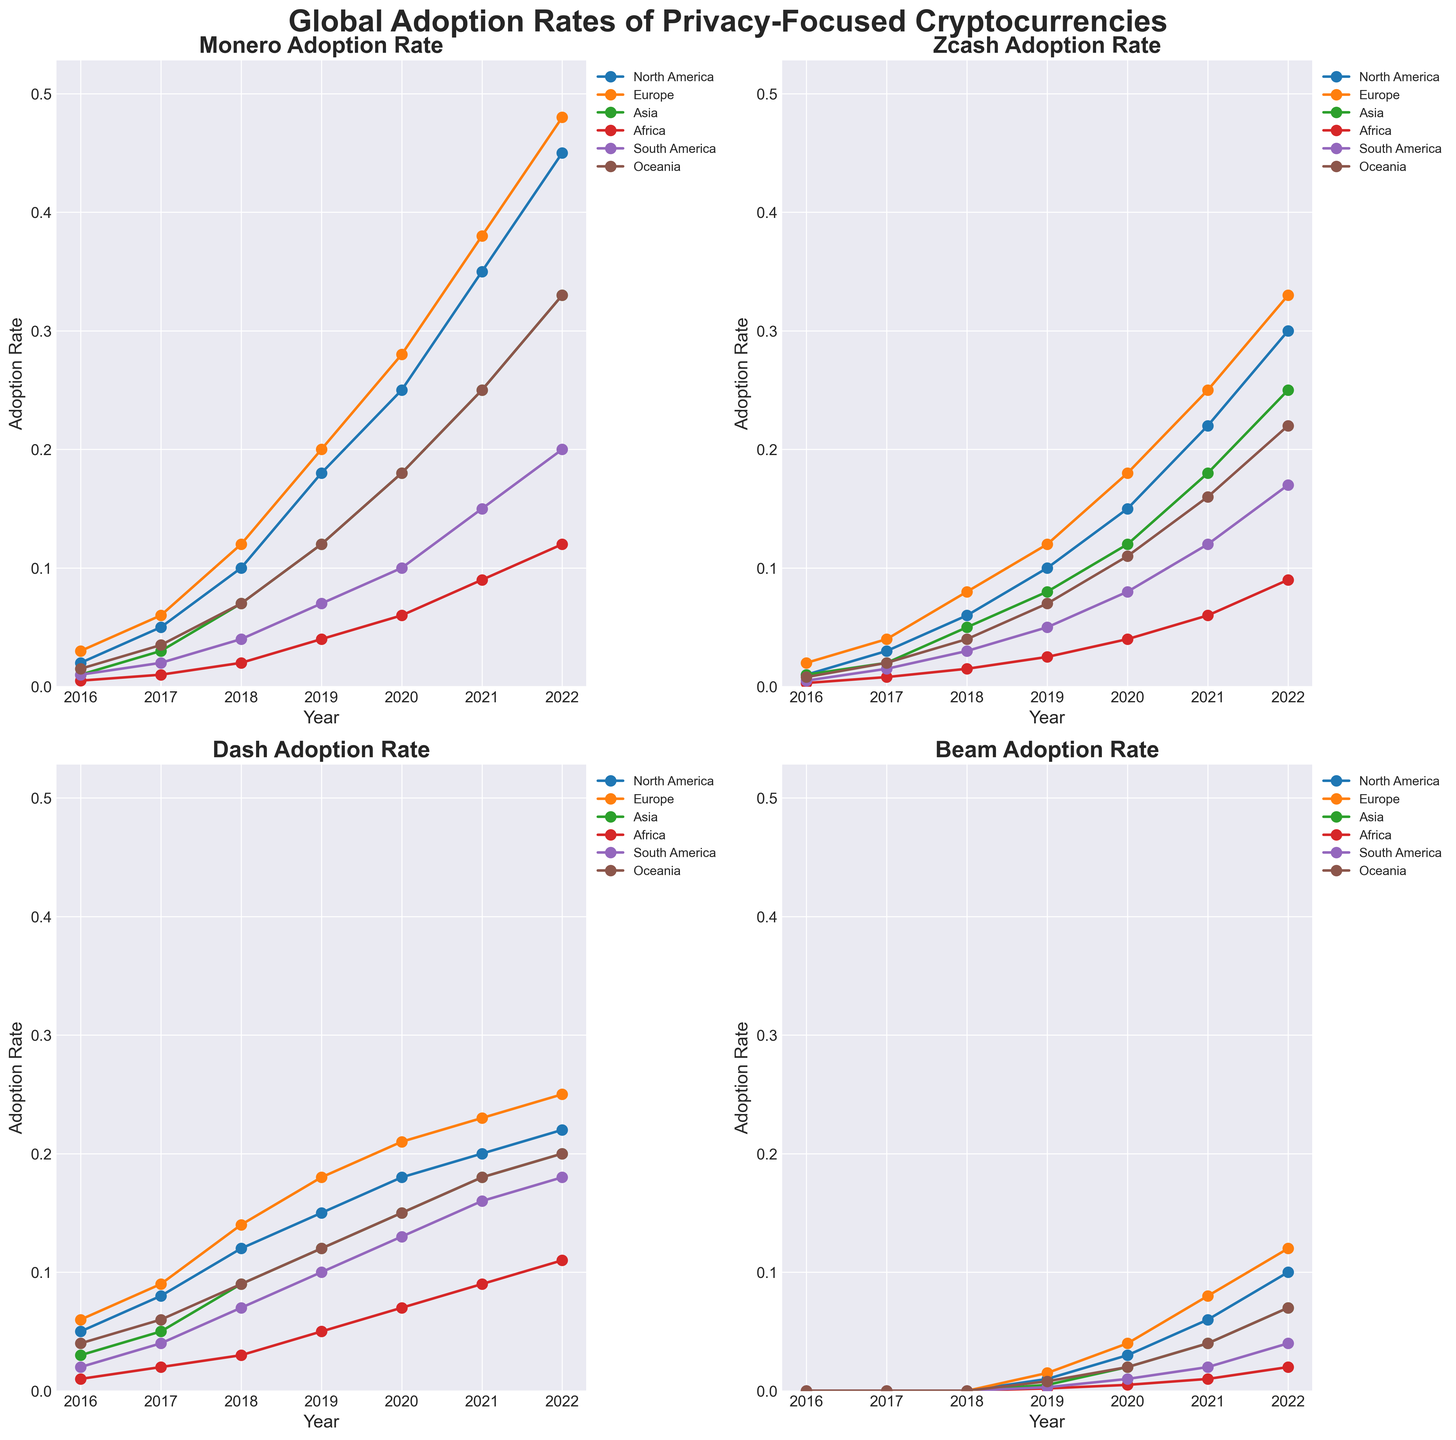What is the adoption rate of Monero in North America in 2021? Look at the subplot for Monero, and find the line representing North America. Follow the line to 2021 on the x-axis to find the adoption rate.
Answer: 0.35 Comparing Europe and Asia, which region had a higher adoption rate of Zcash in 2019? Look at the subplot for Zcash, and find the lines representing Europe and Asia. Compare the points for 2019 on the x-axis to see which has a higher value.
Answer: Europe What was the increase in adoption rate of Dash in South America from 2020 to 2022? Look at the subplot for Dash, find the line representing South America, and note the adoption rates for 2020 and 2022. Subtract the 2020 rate from the 2022 rate.
Answer: 0.05 Which cryptocurrency had the highest adoption rate in Africa in 2022? Look at all subplots, find the lines representing Africa, and compare the values for 2022 to determine which is the highest.
Answer: Dash What is the average adoption rate of Beam in Oceania from 2019 to 2021? Look at the subplot for Beam and find the line representing Oceania. Note the adoption rates for 2019, 2020, and 2021 and calculate their average: (0.008 + 0.02 + 0.04) / 3.
Answer: 0.0227 In North America, how much higher was Monero's adoption rate than Dash's in 2020? Look at the subplots for Monero and Dash, find the lines representing North America, and note the adoption rates for 2020. Subtract Dash's rate from Monero's rate: 0.25 - 0.18.
Answer: 0.07 What trend can be observed for Monero's adoption rate in Europe from 2016 to 2022? Look at the subplot for Monero and find the line representing Europe. Observe the general direction of the line from 2016 to 2022, which shows a consistent increase.
Answer: Increasing trend How does the adoption rate of Beam in Asia in 2022 compare to that in North America in 2021? Look at the subplot for Beam, find the lines representing Asia and North America, and compare the adoption rates for 2022 and 2021, respectively.
Answer: Asia's rate is lower Which cryptocurrency saw the most rapid increase in adoption rate in Europe between 2020 and 2022? Look at all subplots, find the lines representing Europe, and calculate the differences in adoption rates between 2020 and 2022. Identify the cryptocurrency with the largest increase.
Answer: Monero What can you infer about the popularity of privacy-focused cryptocurrencies in Africa compared to other regions by 2022? Look at all subplots and compare the adoption rates in Africa with those in other regions for 2022. Africa generally has lower adoption rates.
Answer: Lower popularity 